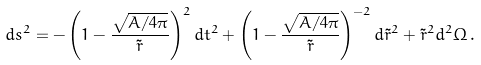Convert formula to latex. <formula><loc_0><loc_0><loc_500><loc_500>d s ^ { 2 } = - \left ( 1 - { \frac { \sqrt { A / 4 \pi } } { \tilde { r } } } \right ) ^ { 2 } d t ^ { 2 } + \left ( 1 - { \frac { \sqrt { A / 4 \pi } } { \tilde { r } } } \right ) ^ { - 2 } d \tilde { r } ^ { 2 } + \tilde { r } ^ { 2 } d ^ { 2 } \Omega \, .</formula> 